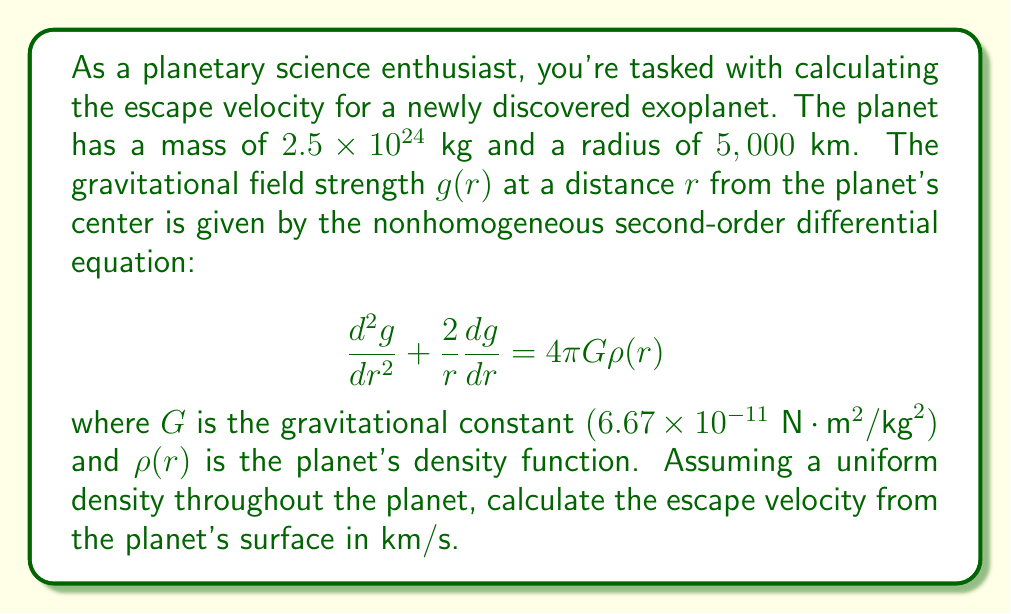Give your solution to this math problem. Let's approach this step-by-step:

1) First, we need to understand that the escape velocity $v_e$ is given by:

   $$v_e = \sqrt{\frac{2GM}{R}}$$

   where $M$ is the mass of the planet and $R$ is its radius.

2) We're given $M = 2.5 \times 10^{24}$ kg and $R = 5,000$ km $= 5 \times 10^6$ m.

3) The differential equation given describes the gravitational field, but we don't need to solve it directly for this problem. The uniform density assumption simplifies our calculation.

4) For a uniform density planet, we can use the simple form of Newton's law of gravitation:

   $$g = \frac{GM}{R^2}$$

5) Substituting the values:

   $$g = \frac{(6.67 \times 10^{-11})(2.5 \times 10^{24})}{(5 \times 10^6)^2} = 6.67 \text{ m/s}^2$$

6) Now, let's calculate the escape velocity:

   $$v_e = \sqrt{\frac{2GM}{R}}$$
   
   $$v_e = \sqrt{\frac{2(6.67 \times 10^{-11})(2.5 \times 10^{24})}{5 \times 10^6}}$$

7) Simplifying:

   $$v_e = \sqrt{66,700,000} \approx 8,167 \text{ m/s}$$

8) Converting to km/s:

   $$v_e \approx 8.17 \text{ km/s}$$

Thus, the escape velocity from the surface of this exoplanet is approximately 8.17 km/s.
Answer: $8.17 \text{ km/s}$ 